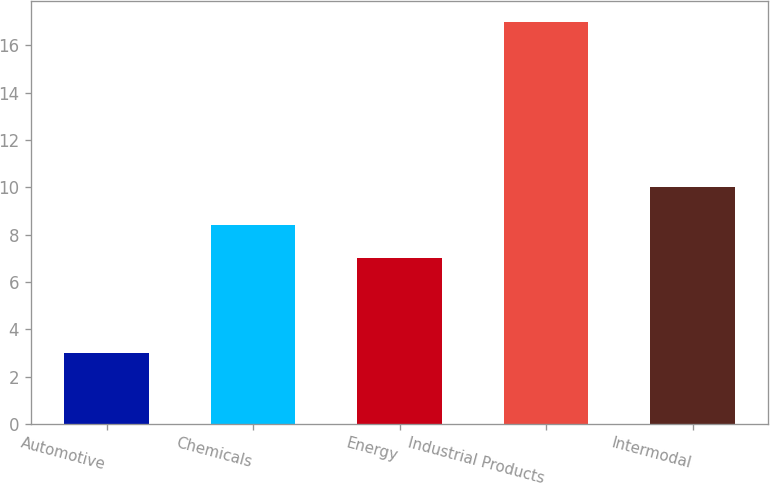Convert chart. <chart><loc_0><loc_0><loc_500><loc_500><bar_chart><fcel>Automotive<fcel>Chemicals<fcel>Energy<fcel>Industrial Products<fcel>Intermodal<nl><fcel>3<fcel>8.4<fcel>7<fcel>17<fcel>10<nl></chart> 